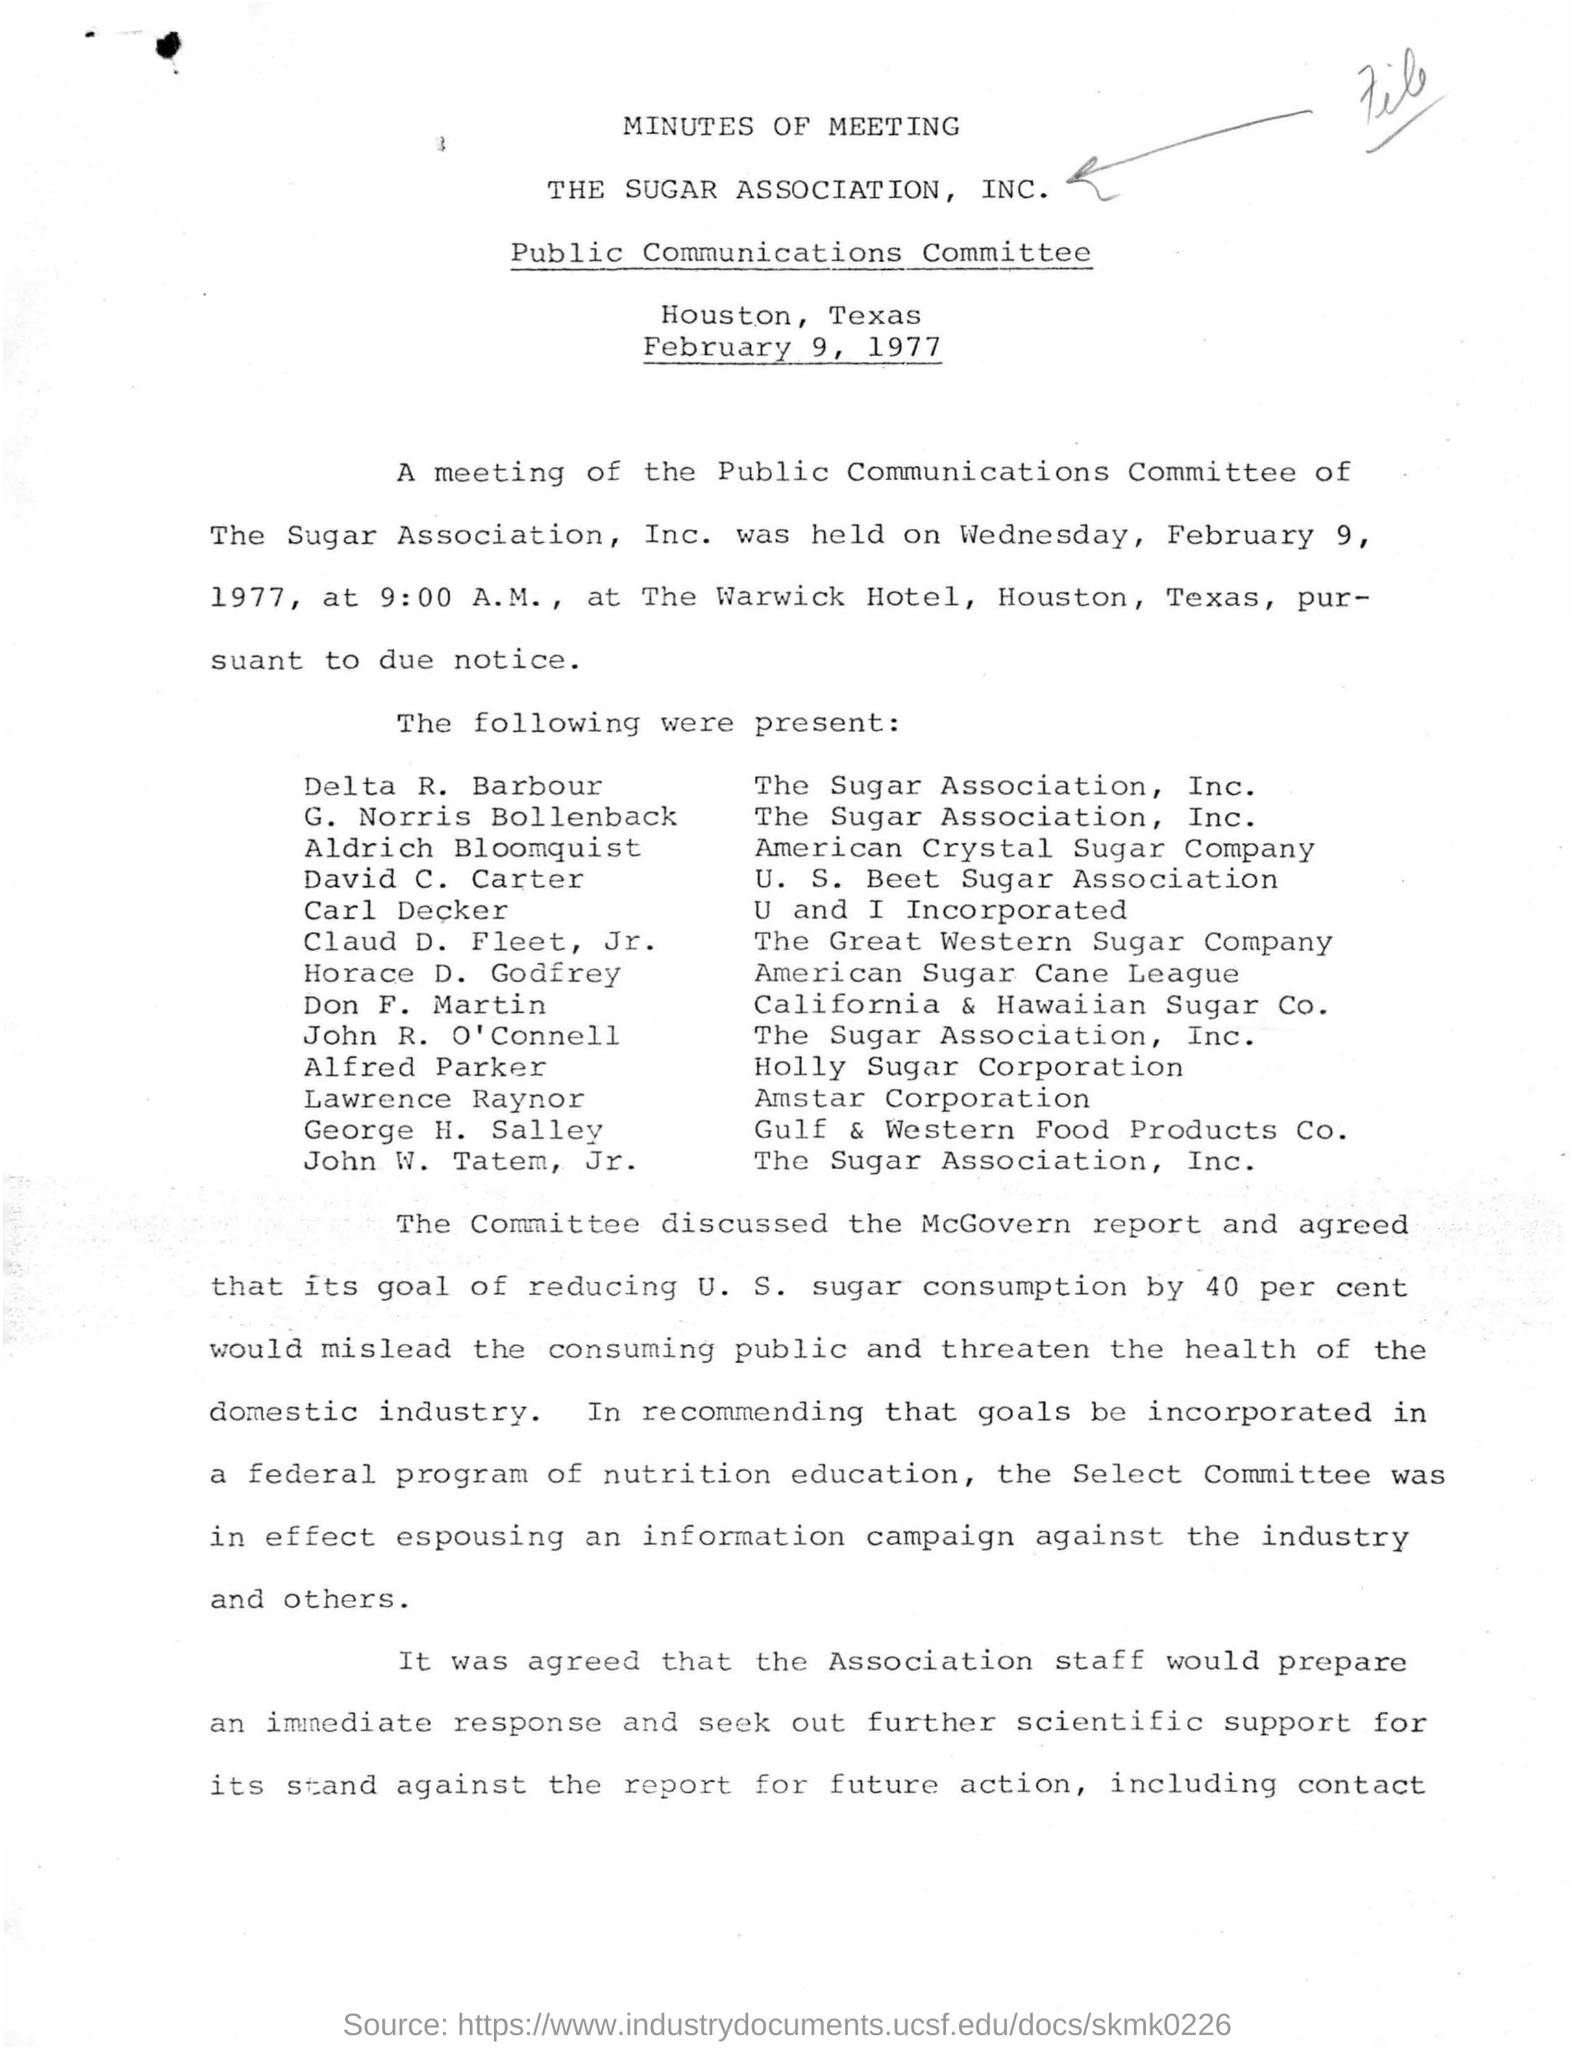Outline some significant characteristics in this image. The name of the committee mentioned is the Public Communications Committee. The meeting was scheduled to take place at a hotel called Warwick. The association mentioned is called the Sugar Association, Inc. The meeting was scheduled for 9:00. The date mentioned in the given page is February 9, 1977. 